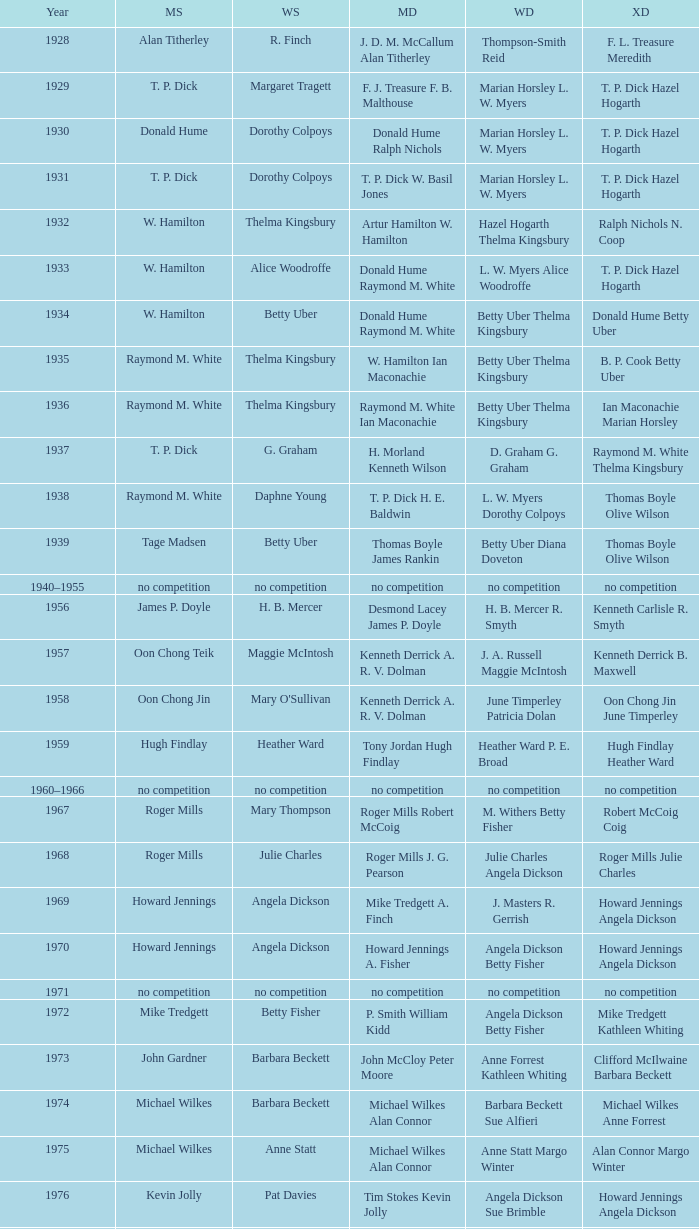When billy gilliland and karen puttick secured the mixed doubles title, who came out on top in the women's doubles? Jane Webster Karen Puttick. 